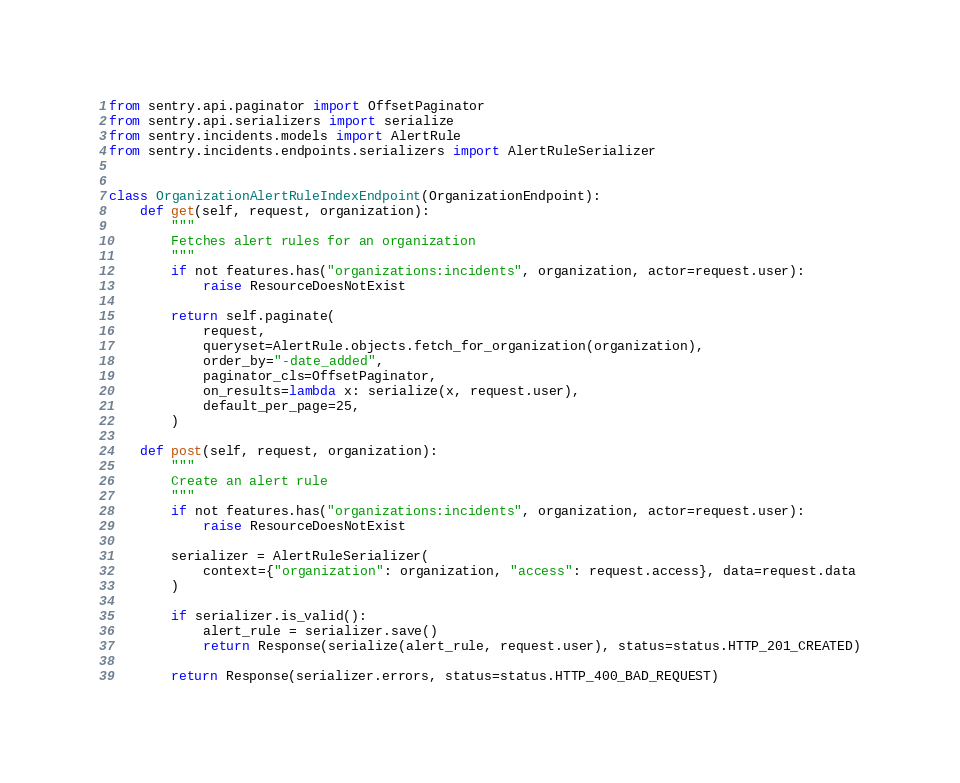<code> <loc_0><loc_0><loc_500><loc_500><_Python_>from sentry.api.paginator import OffsetPaginator
from sentry.api.serializers import serialize
from sentry.incidents.models import AlertRule
from sentry.incidents.endpoints.serializers import AlertRuleSerializer


class OrganizationAlertRuleIndexEndpoint(OrganizationEndpoint):
    def get(self, request, organization):
        """
        Fetches alert rules for an organization
        """
        if not features.has("organizations:incidents", organization, actor=request.user):
            raise ResourceDoesNotExist

        return self.paginate(
            request,
            queryset=AlertRule.objects.fetch_for_organization(organization),
            order_by="-date_added",
            paginator_cls=OffsetPaginator,
            on_results=lambda x: serialize(x, request.user),
            default_per_page=25,
        )

    def post(self, request, organization):
        """
        Create an alert rule
        """
        if not features.has("organizations:incidents", organization, actor=request.user):
            raise ResourceDoesNotExist

        serializer = AlertRuleSerializer(
            context={"organization": organization, "access": request.access}, data=request.data
        )

        if serializer.is_valid():
            alert_rule = serializer.save()
            return Response(serialize(alert_rule, request.user), status=status.HTTP_201_CREATED)

        return Response(serializer.errors, status=status.HTTP_400_BAD_REQUEST)
</code> 